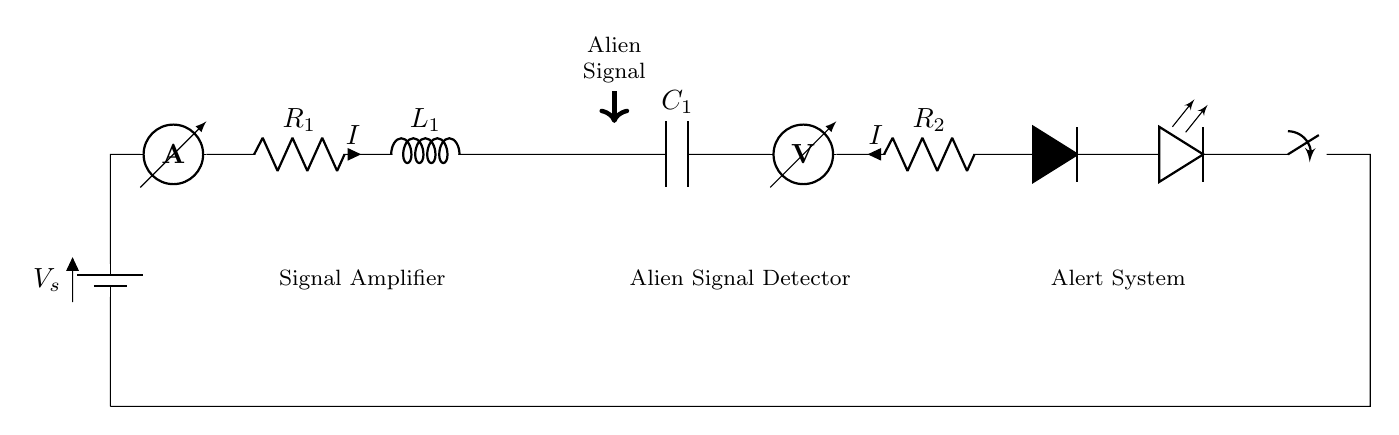What is the type of power source in the circuit? The circuit uses a battery, specifically indicated by the symbol for a battery at the left side of the diagram, labeled as \( V_s \).
Answer: battery What is the function of the component labeled R1? R1 acts as a signal amplifier to boost the strength of the incoming alien signal, indicated by the labeling in the circuit diagram.
Answer: signal amplifier How many resistors are in this circuit? There are two resistors visible in the circuit diagram, R1 and R2, which are indicated by the resistor symbols in series.
Answer: two What component signals an alien presence? The antenna component, which is positioned between the inductor and capacitor, is specifically designated for detecting an alien signal, as suggested by the label.
Answer: antenna What happens when the switch is closed? Closing the switch completes the circuit path, allowing current to flow through to the LED indicator, signaling that an alien presence has been detected, as described in the circuit flow.
Answer: current flows What type of capacitor is in this circuit? The circuit includes a standard capacitor labeled C1, which is designed to store electrical energy. It is indicated by the specific capacitor symbol in the diagram.
Answer: standard capacitor What does the voltmeter measure in this circuit? The voltmeter, located toward the right of the C1 component, measures the voltage across R2, providing an indication of the potential difference in the circuit once the alien signal is detected.
Answer: voltage across R2 